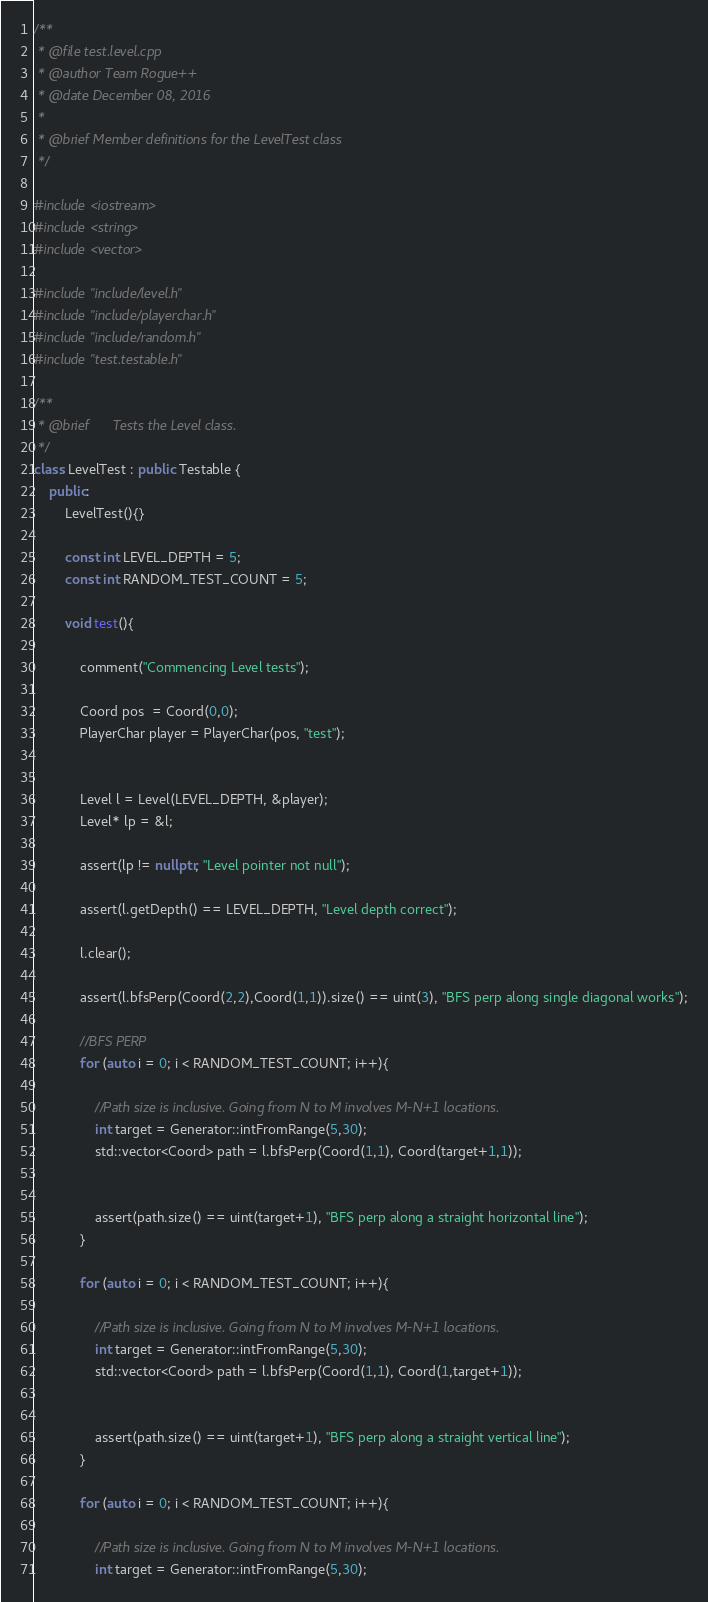<code> <loc_0><loc_0><loc_500><loc_500><_C++_>/**
 * @file test.level.cpp
 * @author Team Rogue++
 * @date December 08, 2016
 *
 * @brief Member definitions for the LevelTest class
 */ 

#include <iostream>
#include <string>
#include <vector>

#include "include/level.h"
#include "include/playerchar.h"
#include "include/random.h"
#include "test.testable.h"

/**
 * @brief      Tests the Level class.
 */
class LevelTest : public Testable {
	public:
		LevelTest(){}

		const int LEVEL_DEPTH = 5;
		const int RANDOM_TEST_COUNT = 5;

		void test(){

			comment("Commencing Level tests");

			Coord pos  = Coord(0,0);
			PlayerChar player = PlayerChar(pos, "test");


			Level l = Level(LEVEL_DEPTH, &player);
			Level* lp = &l;

			assert(lp != nullptr, "Level pointer not null");

			assert(l.getDepth() == LEVEL_DEPTH, "Level depth correct");

			l.clear();

			assert(l.bfsPerp(Coord(2,2),Coord(1,1)).size() == uint(3), "BFS perp along single diagonal works");

			//BFS PERP
			for (auto i = 0; i < RANDOM_TEST_COUNT; i++){

				//Path size is inclusive. Going from N to M involves M-N+1 locations.
				int target = Generator::intFromRange(5,30);
				std::vector<Coord> path = l.bfsPerp(Coord(1,1), Coord(target+1,1));


				assert(path.size() == uint(target+1), "BFS perp along a straight horizontal line");
			}

			for (auto i = 0; i < RANDOM_TEST_COUNT; i++){

				//Path size is inclusive. Going from N to M involves M-N+1 locations.
				int target = Generator::intFromRange(5,30);
				std::vector<Coord> path = l.bfsPerp(Coord(1,1), Coord(1,target+1));


				assert(path.size() == uint(target+1), "BFS perp along a straight vertical line");
			}

			for (auto i = 0; i < RANDOM_TEST_COUNT; i++){

				//Path size is inclusive. Going from N to M involves M-N+1 locations.
				int target = Generator::intFromRange(5,30);</code> 